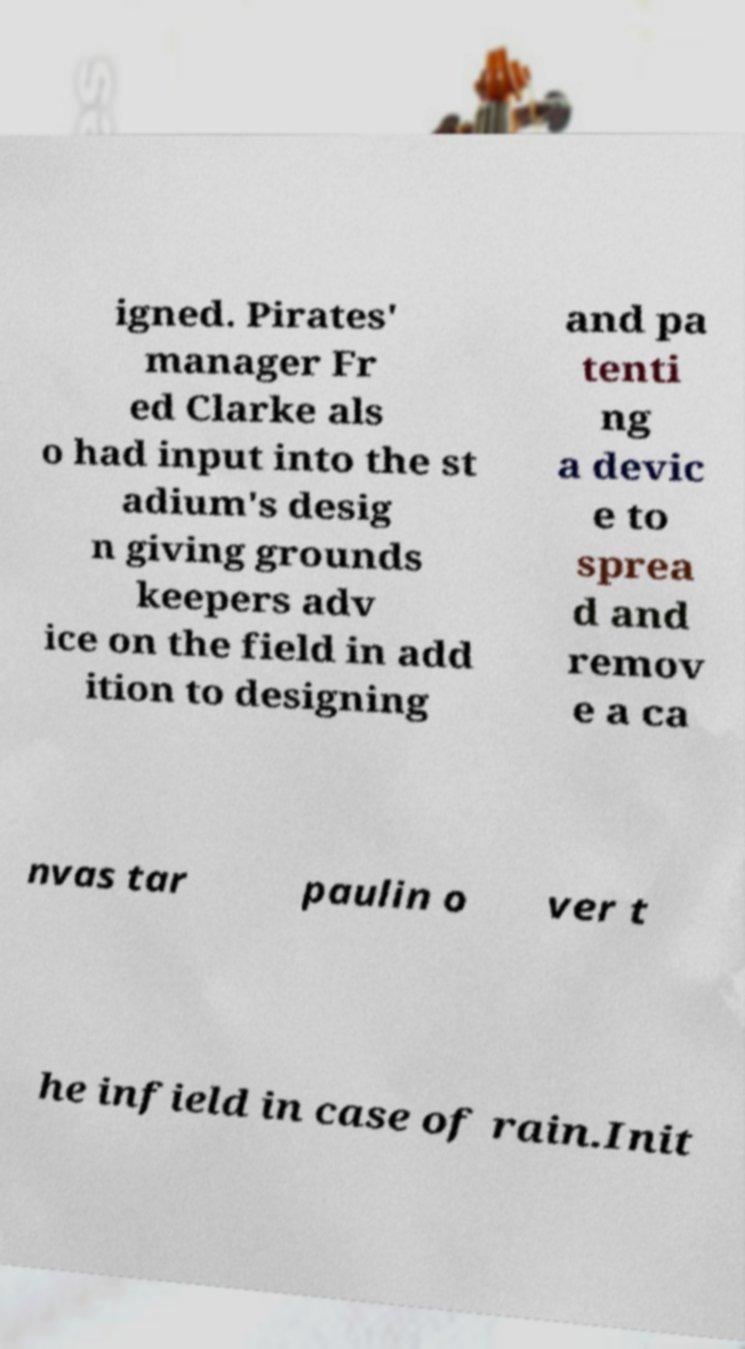Could you assist in decoding the text presented in this image and type it out clearly? igned. Pirates' manager Fr ed Clarke als o had input into the st adium's desig n giving grounds keepers adv ice on the field in add ition to designing and pa tenti ng a devic e to sprea d and remov e a ca nvas tar paulin o ver t he infield in case of rain.Init 